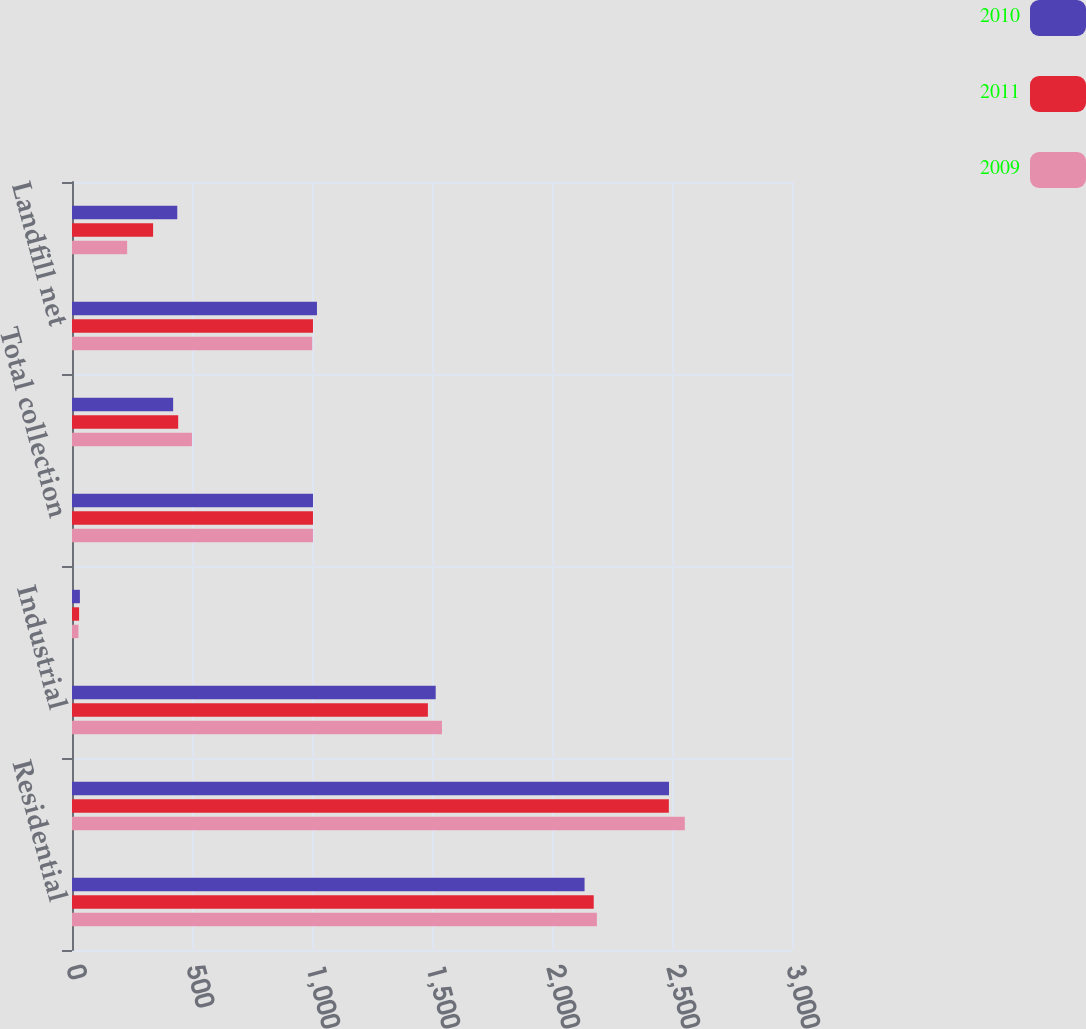Convert chart. <chart><loc_0><loc_0><loc_500><loc_500><stacked_bar_chart><ecel><fcel>Residential<fcel>Commercial<fcel>Industrial<fcel>Other<fcel>Total collection<fcel>Transfer net<fcel>Landfill net<fcel>Sale of recyclable materials<nl><fcel>2010<fcel>2135.7<fcel>2487.5<fcel>1515.4<fcel>32.9<fcel>1004.1<fcel>421.4<fcel>1020.7<fcel>438.6<nl><fcel>2011<fcel>2173.9<fcel>2486.8<fcel>1482.9<fcel>29.6<fcel>1004.1<fcel>442.4<fcel>1004.1<fcel>337.9<nl><fcel>2009<fcel>2187<fcel>2553.4<fcel>1541.4<fcel>26.9<fcel>1004.1<fcel>499.9<fcel>1000.9<fcel>229.8<nl></chart> 